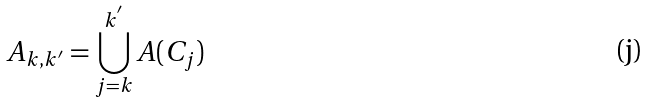Convert formula to latex. <formula><loc_0><loc_0><loc_500><loc_500>A _ { k , k ^ { ^ { \prime } } } = \bigcup _ { j = k } ^ { k ^ { ^ { \prime } } } A ( C _ { j } )</formula> 